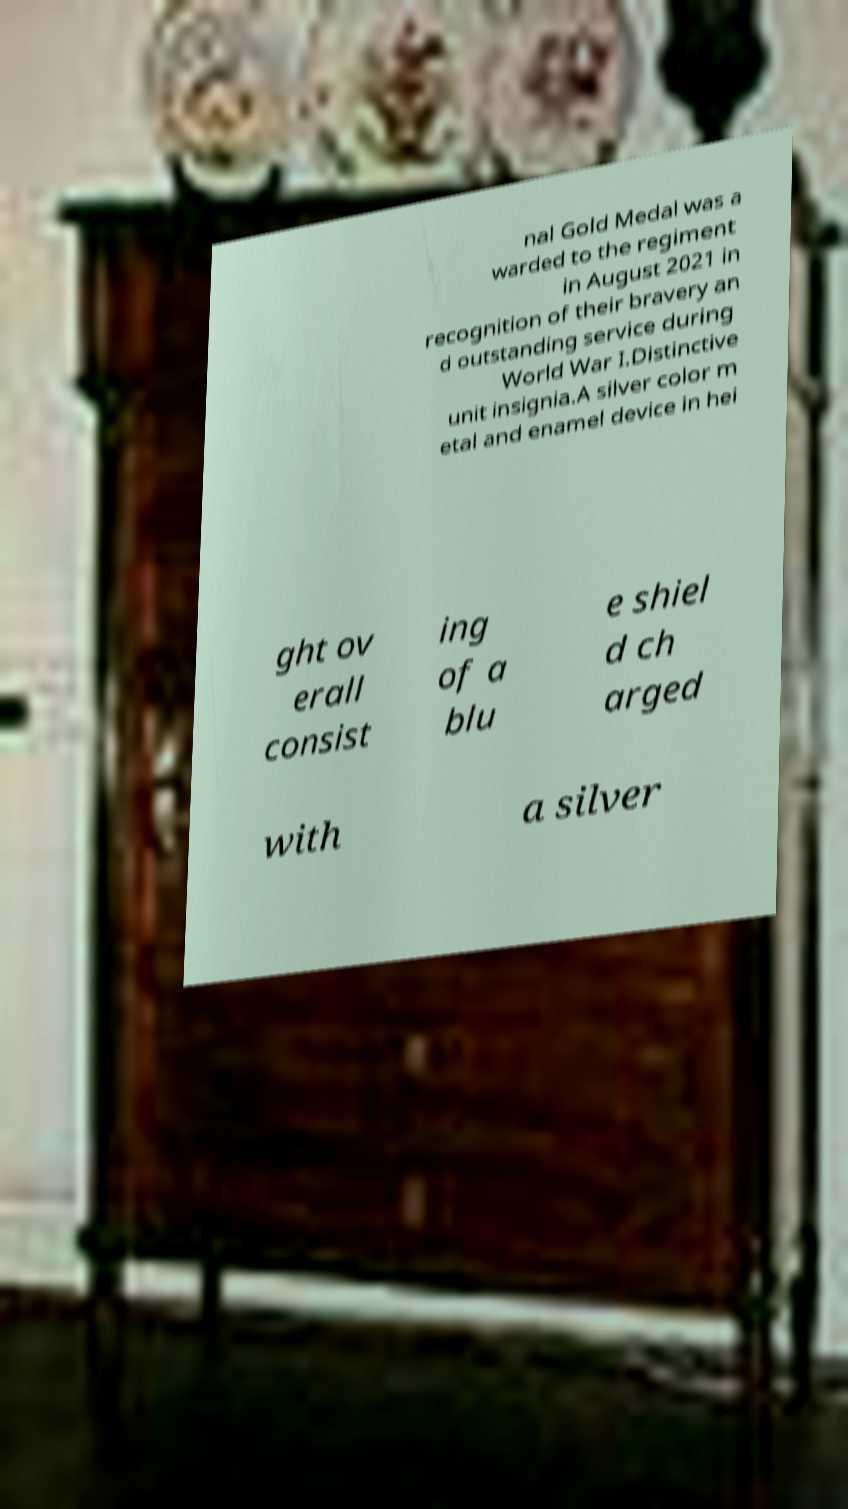Could you extract and type out the text from this image? nal Gold Medal was a warded to the regiment in August 2021 in recognition of their bravery an d outstanding service during World War I.Distinctive unit insignia.A silver color m etal and enamel device in hei ght ov erall consist ing of a blu e shiel d ch arged with a silver 